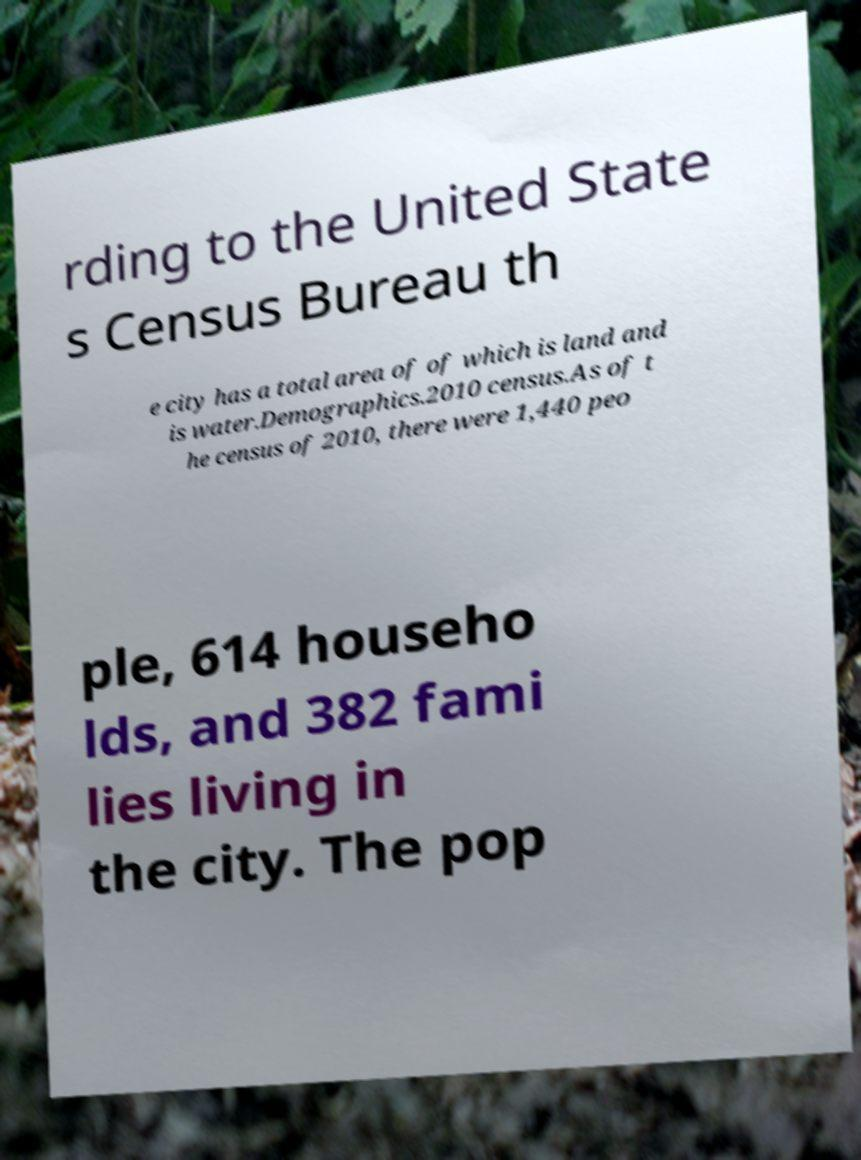Could you assist in decoding the text presented in this image and type it out clearly? rding to the United State s Census Bureau th e city has a total area of of which is land and is water.Demographics.2010 census.As of t he census of 2010, there were 1,440 peo ple, 614 househo lds, and 382 fami lies living in the city. The pop 